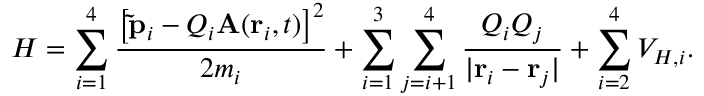Convert formula to latex. <formula><loc_0><loc_0><loc_500><loc_500>H = \sum _ { i = 1 } ^ { 4 } \frac { \left [ \tilde { p } _ { i } - Q _ { i } A ( r _ { i } , t ) \right ] ^ { 2 } } { 2 m _ { i } } + \sum _ { i = 1 } ^ { 3 } \sum _ { j = i + 1 } ^ { 4 } \frac { Q _ { i } Q _ { j } } { | r _ { i } - r _ { j } | } + \sum _ { i = 2 } ^ { 4 } V _ { H , i } .</formula> 